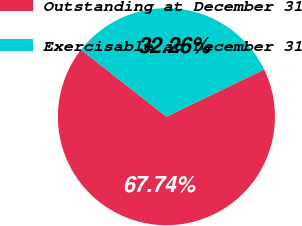Convert chart. <chart><loc_0><loc_0><loc_500><loc_500><pie_chart><fcel>Outstanding at December 31<fcel>Exercisable at December 31<nl><fcel>67.74%<fcel>32.26%<nl></chart> 